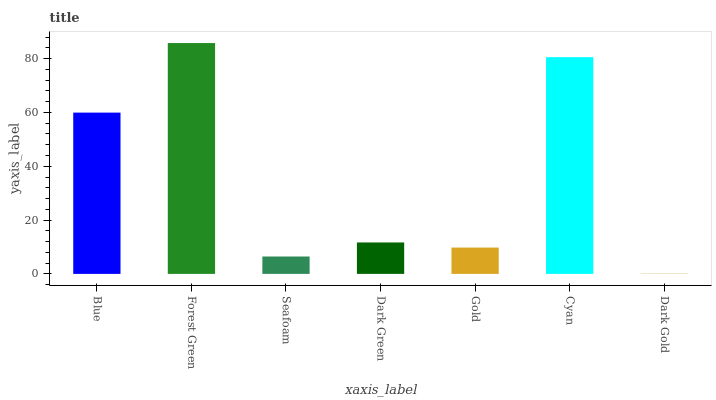Is Seafoam the minimum?
Answer yes or no. No. Is Seafoam the maximum?
Answer yes or no. No. Is Forest Green greater than Seafoam?
Answer yes or no. Yes. Is Seafoam less than Forest Green?
Answer yes or no. Yes. Is Seafoam greater than Forest Green?
Answer yes or no. No. Is Forest Green less than Seafoam?
Answer yes or no. No. Is Dark Green the high median?
Answer yes or no. Yes. Is Dark Green the low median?
Answer yes or no. Yes. Is Blue the high median?
Answer yes or no. No. Is Blue the low median?
Answer yes or no. No. 